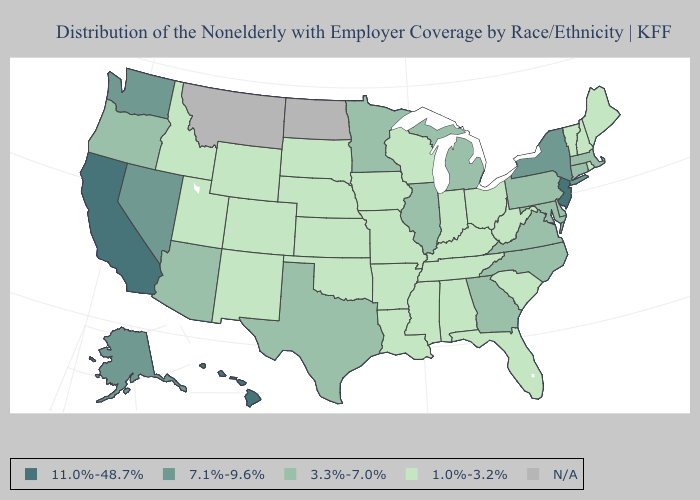What is the value of Connecticut?
Write a very short answer. 3.3%-7.0%. What is the lowest value in the Northeast?
Give a very brief answer. 1.0%-3.2%. What is the value of Hawaii?
Keep it brief. 11.0%-48.7%. Does the map have missing data?
Write a very short answer. Yes. Among the states that border New Mexico , which have the highest value?
Quick response, please. Arizona, Texas. What is the value of South Carolina?
Keep it brief. 1.0%-3.2%. Which states have the lowest value in the MidWest?
Answer briefly. Indiana, Iowa, Kansas, Missouri, Nebraska, Ohio, South Dakota, Wisconsin. Among the states that border Pennsylvania , which have the highest value?
Answer briefly. New Jersey. Does Nevada have the lowest value in the USA?
Give a very brief answer. No. What is the value of Wyoming?
Answer briefly. 1.0%-3.2%. Name the states that have a value in the range 1.0%-3.2%?
Concise answer only. Alabama, Arkansas, Colorado, Florida, Idaho, Indiana, Iowa, Kansas, Kentucky, Louisiana, Maine, Mississippi, Missouri, Nebraska, New Hampshire, New Mexico, Ohio, Oklahoma, Rhode Island, South Carolina, South Dakota, Tennessee, Utah, Vermont, West Virginia, Wisconsin, Wyoming. Name the states that have a value in the range 11.0%-48.7%?
Write a very short answer. California, Hawaii, New Jersey. Does the first symbol in the legend represent the smallest category?
Answer briefly. No. Name the states that have a value in the range 7.1%-9.6%?
Keep it brief. Alaska, Nevada, New York, Washington. What is the highest value in the USA?
Answer briefly. 11.0%-48.7%. 